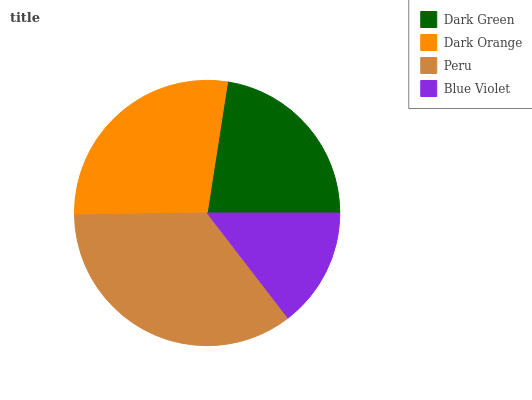Is Blue Violet the minimum?
Answer yes or no. Yes. Is Peru the maximum?
Answer yes or no. Yes. Is Dark Orange the minimum?
Answer yes or no. No. Is Dark Orange the maximum?
Answer yes or no. No. Is Dark Orange greater than Dark Green?
Answer yes or no. Yes. Is Dark Green less than Dark Orange?
Answer yes or no. Yes. Is Dark Green greater than Dark Orange?
Answer yes or no. No. Is Dark Orange less than Dark Green?
Answer yes or no. No. Is Dark Orange the high median?
Answer yes or no. Yes. Is Dark Green the low median?
Answer yes or no. Yes. Is Peru the high median?
Answer yes or no. No. Is Dark Orange the low median?
Answer yes or no. No. 